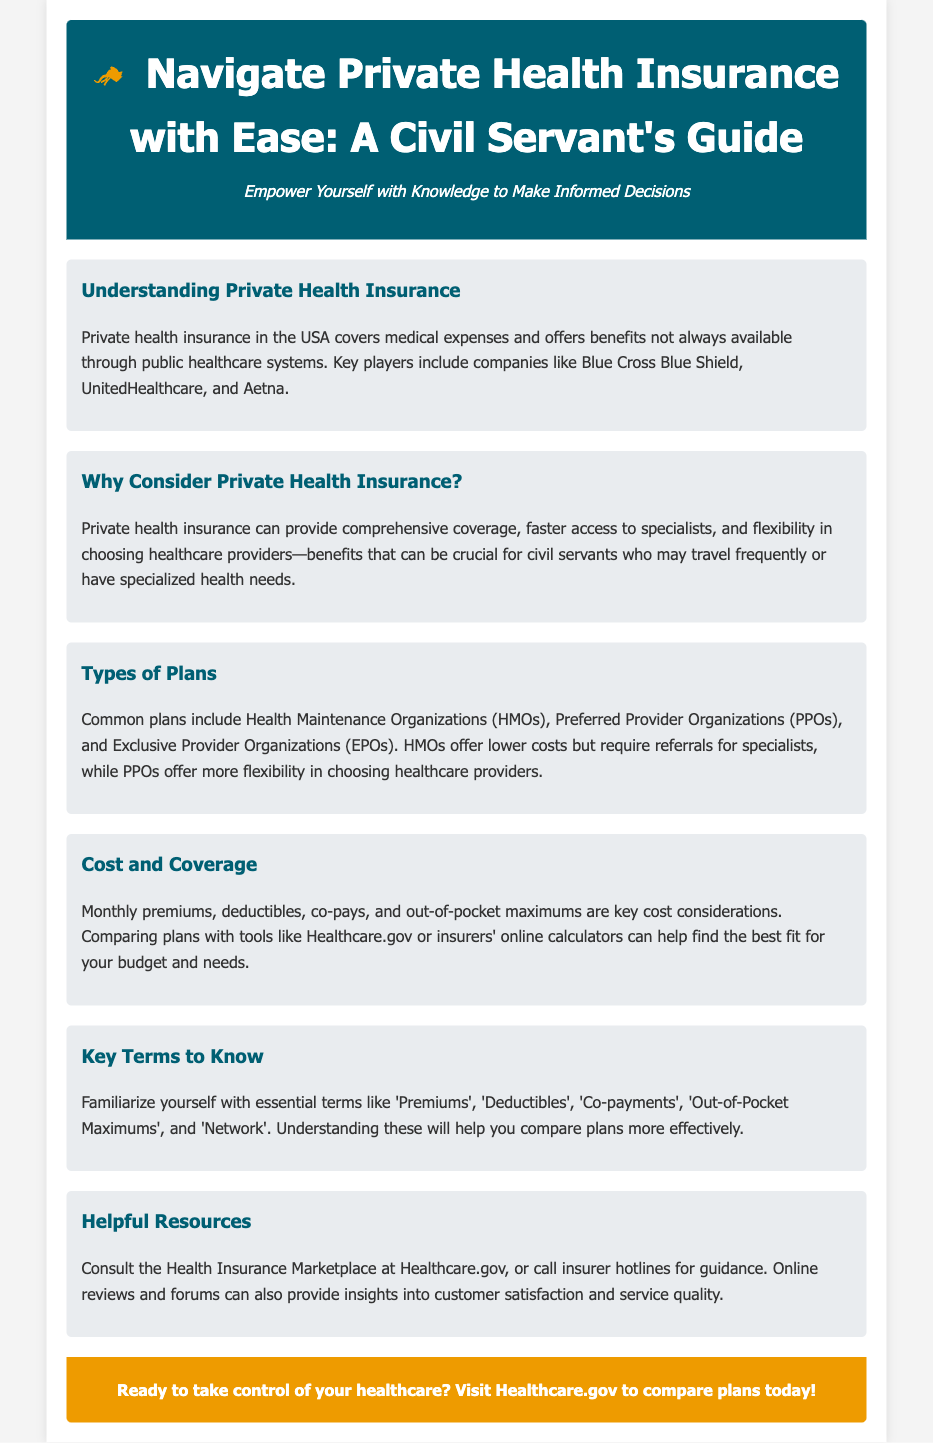what is the title of the guide? The title of the guide provides the main focus of the document, showcasing its purpose to assist civil servants with private health insurance.
Answer: Navigate Private Health Insurance with Ease: A Civil Servant's Guide who are key players in private health insurance? This question seeks specific companies mentioned within the guide that play significant roles in private health insurance.
Answer: Blue Cross Blue Shield, UnitedHealthcare, Aetna what type of health insurance plan offers lower costs but requires referrals? The document outlines different plans, highlighting their unique features, such as cost and referral requirements.
Answer: Health Maintenance Organizations (HMOs) what is a crucial benefit of private health insurance for civil servants? This question focuses on the advantages private health insurance offers specifically for civil servants as mentioned in the document.
Answer: Faster access to specialists which website can help compare health insurance plans? The guide mentions a specific resource that assists in comparing different health insurance plans available.
Answer: Healthcare.gov what do 'Premiums' and 'Deductibles' refer to? This question centers on understanding key insurance terms that are critical for comparing plans effectively.
Answer: Essential terms to know what type of insurance plan offers more flexibility in choosing providers? This inquiry relates to the characteristics of different insurance plans covered in the document.
Answer: Preferred Provider Organizations (PPOs) what should you consult for guidance on health insurance? The document lists resources to help civil servants navigate their health insurance options effectively.
Answer: Health Insurance Marketplace at Healthcare.gov 